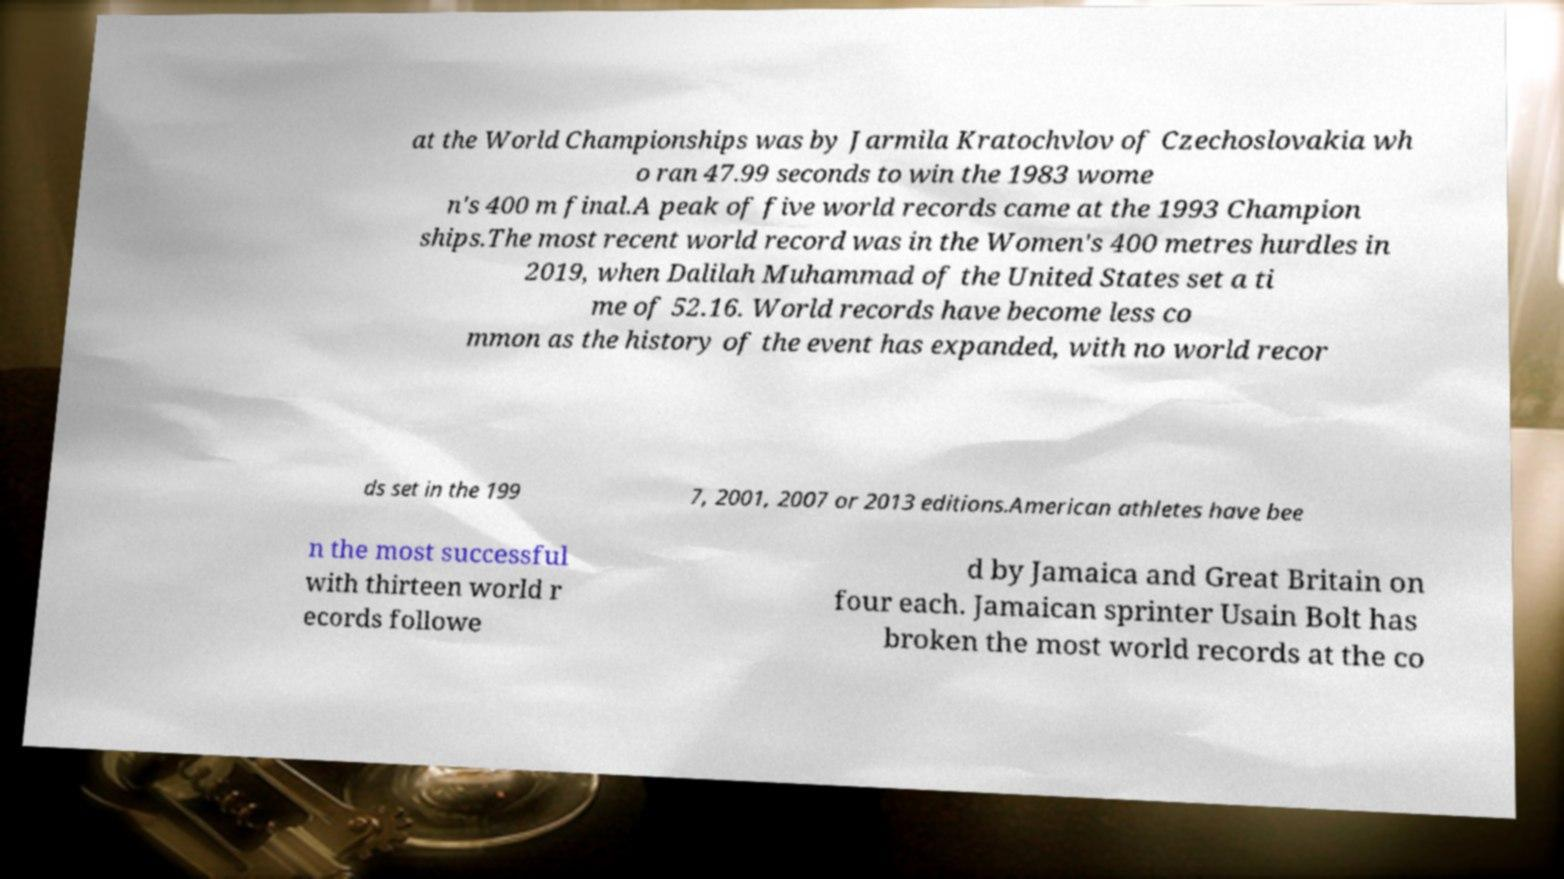There's text embedded in this image that I need extracted. Can you transcribe it verbatim? at the World Championships was by Jarmila Kratochvlov of Czechoslovakia wh o ran 47.99 seconds to win the 1983 wome n's 400 m final.A peak of five world records came at the 1993 Champion ships.The most recent world record was in the Women's 400 metres hurdles in 2019, when Dalilah Muhammad of the United States set a ti me of 52.16. World records have become less co mmon as the history of the event has expanded, with no world recor ds set in the 199 7, 2001, 2007 or 2013 editions.American athletes have bee n the most successful with thirteen world r ecords followe d by Jamaica and Great Britain on four each. Jamaican sprinter Usain Bolt has broken the most world records at the co 